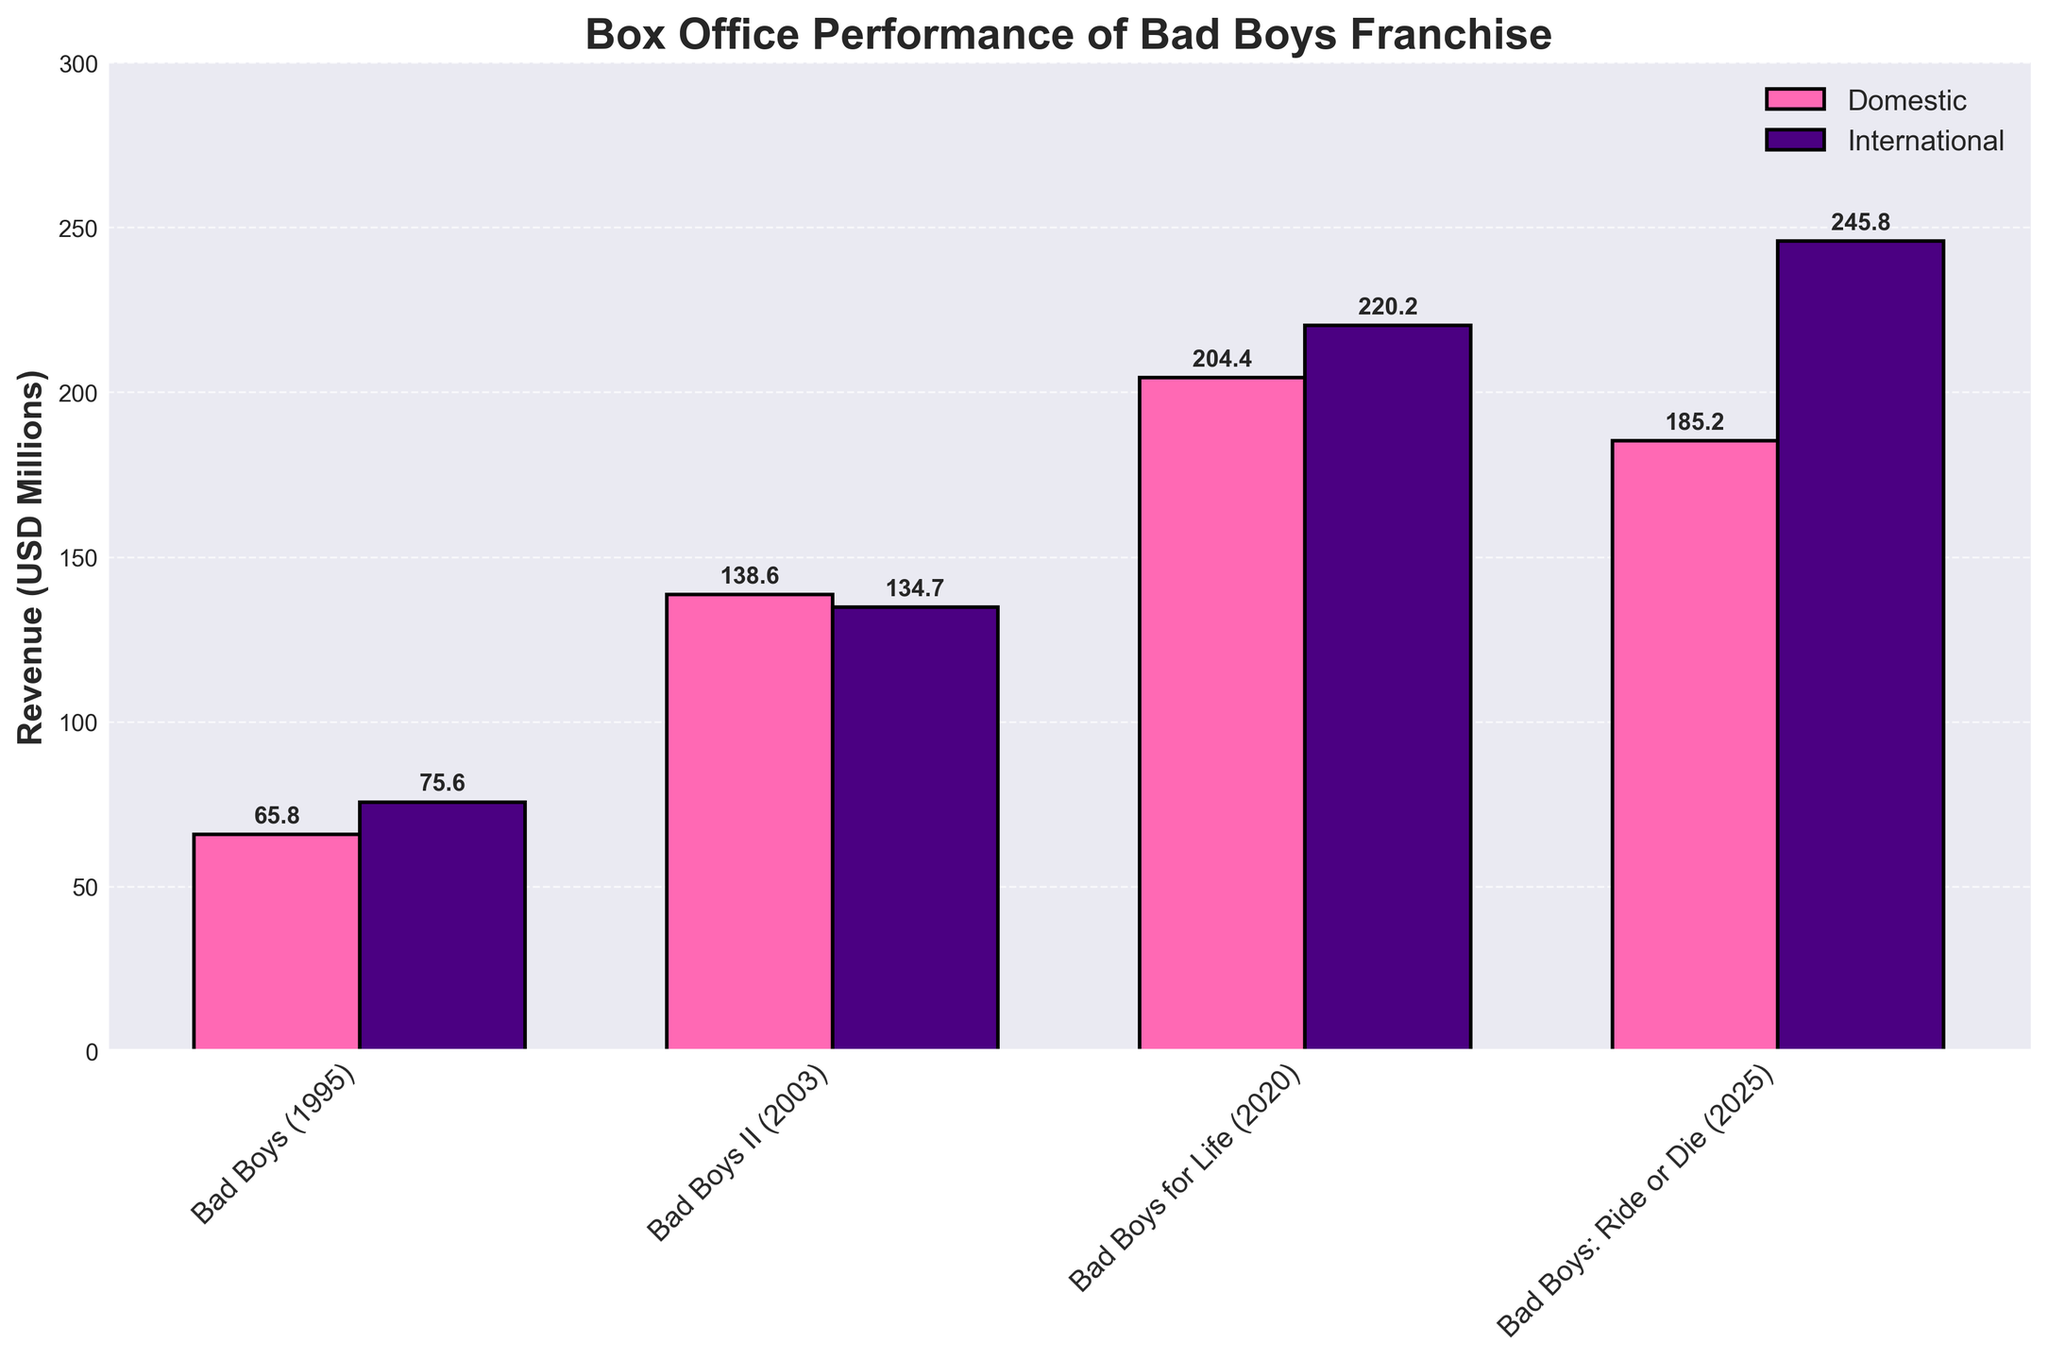Which movie has the highest total revenue? By looking at the highest bars for both domestic and international revenue combined, we can see that "Bad Boys for Life" has the highest total revenue.
Answer: Bad Boys for Life What is the total revenue for "Bad Boys: Ride or Die"? Sum the domestic revenue (185.2 million) and the international revenue (245.8 million) for "Bad Boys: Ride or Die". 185.2 + 245.8 = 431 million
Answer: 431 million Which movie had greater international revenue compared to domestic revenue? Comparing the heights of the international and domestic bars for each movie, we see that "Bad Boys for Life" and "Bad Boys: Ride or Die" had higher international revenues.
Answer: Bad Boys for Life and Bad Boys: Ride or Die What is the difference between the domestic and international revenue of "Bad Boys II"? Subtract the domestic revenue (138.6 million) from the international revenue (134.7 million) for "Bad Boys II". 138.6 - 134.7 = 3.9 million
Answer: 3.9 million Which movie had the lowest domestic revenue? Looking at the heights of the domestic revenue bars, "Bad Boys (1995)" had the lowest domestic revenue.
Answer: Bad Boys (1995) How does the domestic revenue of "Bad Boys (1995)" compare to "Bad Boys for Life"? The bar representing domestic revenue for "Bad Boys (1995)" is significantly shorter than that of "Bad Boys for Life", indicating that "Bad Boys for Life" had much higher domestic revenue.
Answer: Bad Boys for Life is higher What is the average international revenue of the movies in the franchise? Sum the international revenues of all movies (75.6 + 134.7 + 220.2 + 245.8) and divide by the number of movies (4). (75.6 + 134.7 + 220.2 + 245.8) / 4 = 169.075 million
Answer: 169.075 million Which movie had similar domestic and international revenue? "Bad Boys II" had very similar domestic (138.6 million) and international revenue (134.7 million).
Answer: Bad Boys II 